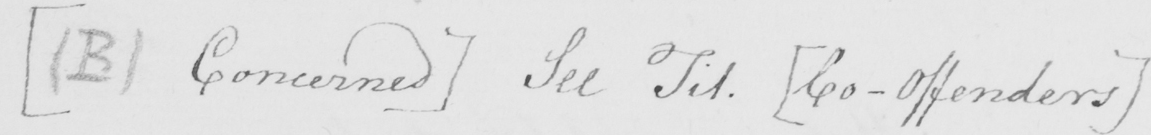Transcribe the text shown in this historical manuscript line. [  ( B )  Concerned ]  See Tit .  [ Co-Offenders ] 